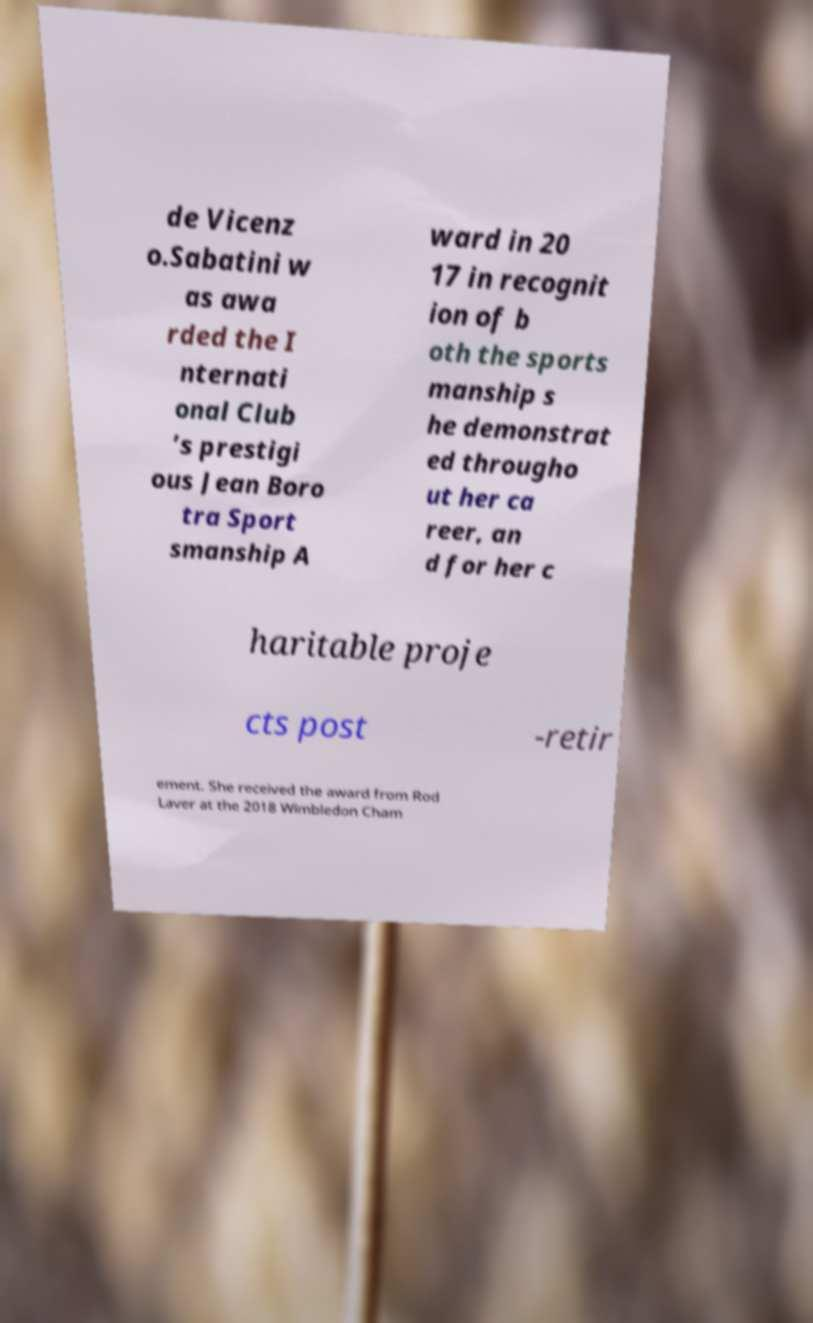Could you extract and type out the text from this image? de Vicenz o.Sabatini w as awa rded the I nternati onal Club ’s prestigi ous Jean Boro tra Sport smanship A ward in 20 17 in recognit ion of b oth the sports manship s he demonstrat ed througho ut her ca reer, an d for her c haritable proje cts post -retir ement. She received the award from Rod Laver at the 2018 Wimbledon Cham 